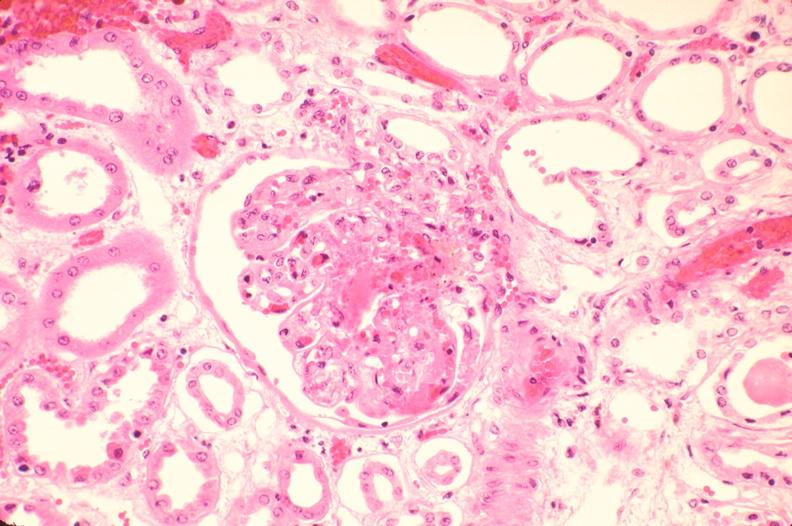does this image show kidney, microthrombi, thrombotic thrombocytopenic purpura?
Answer the question using a single word or phrase. Yes 